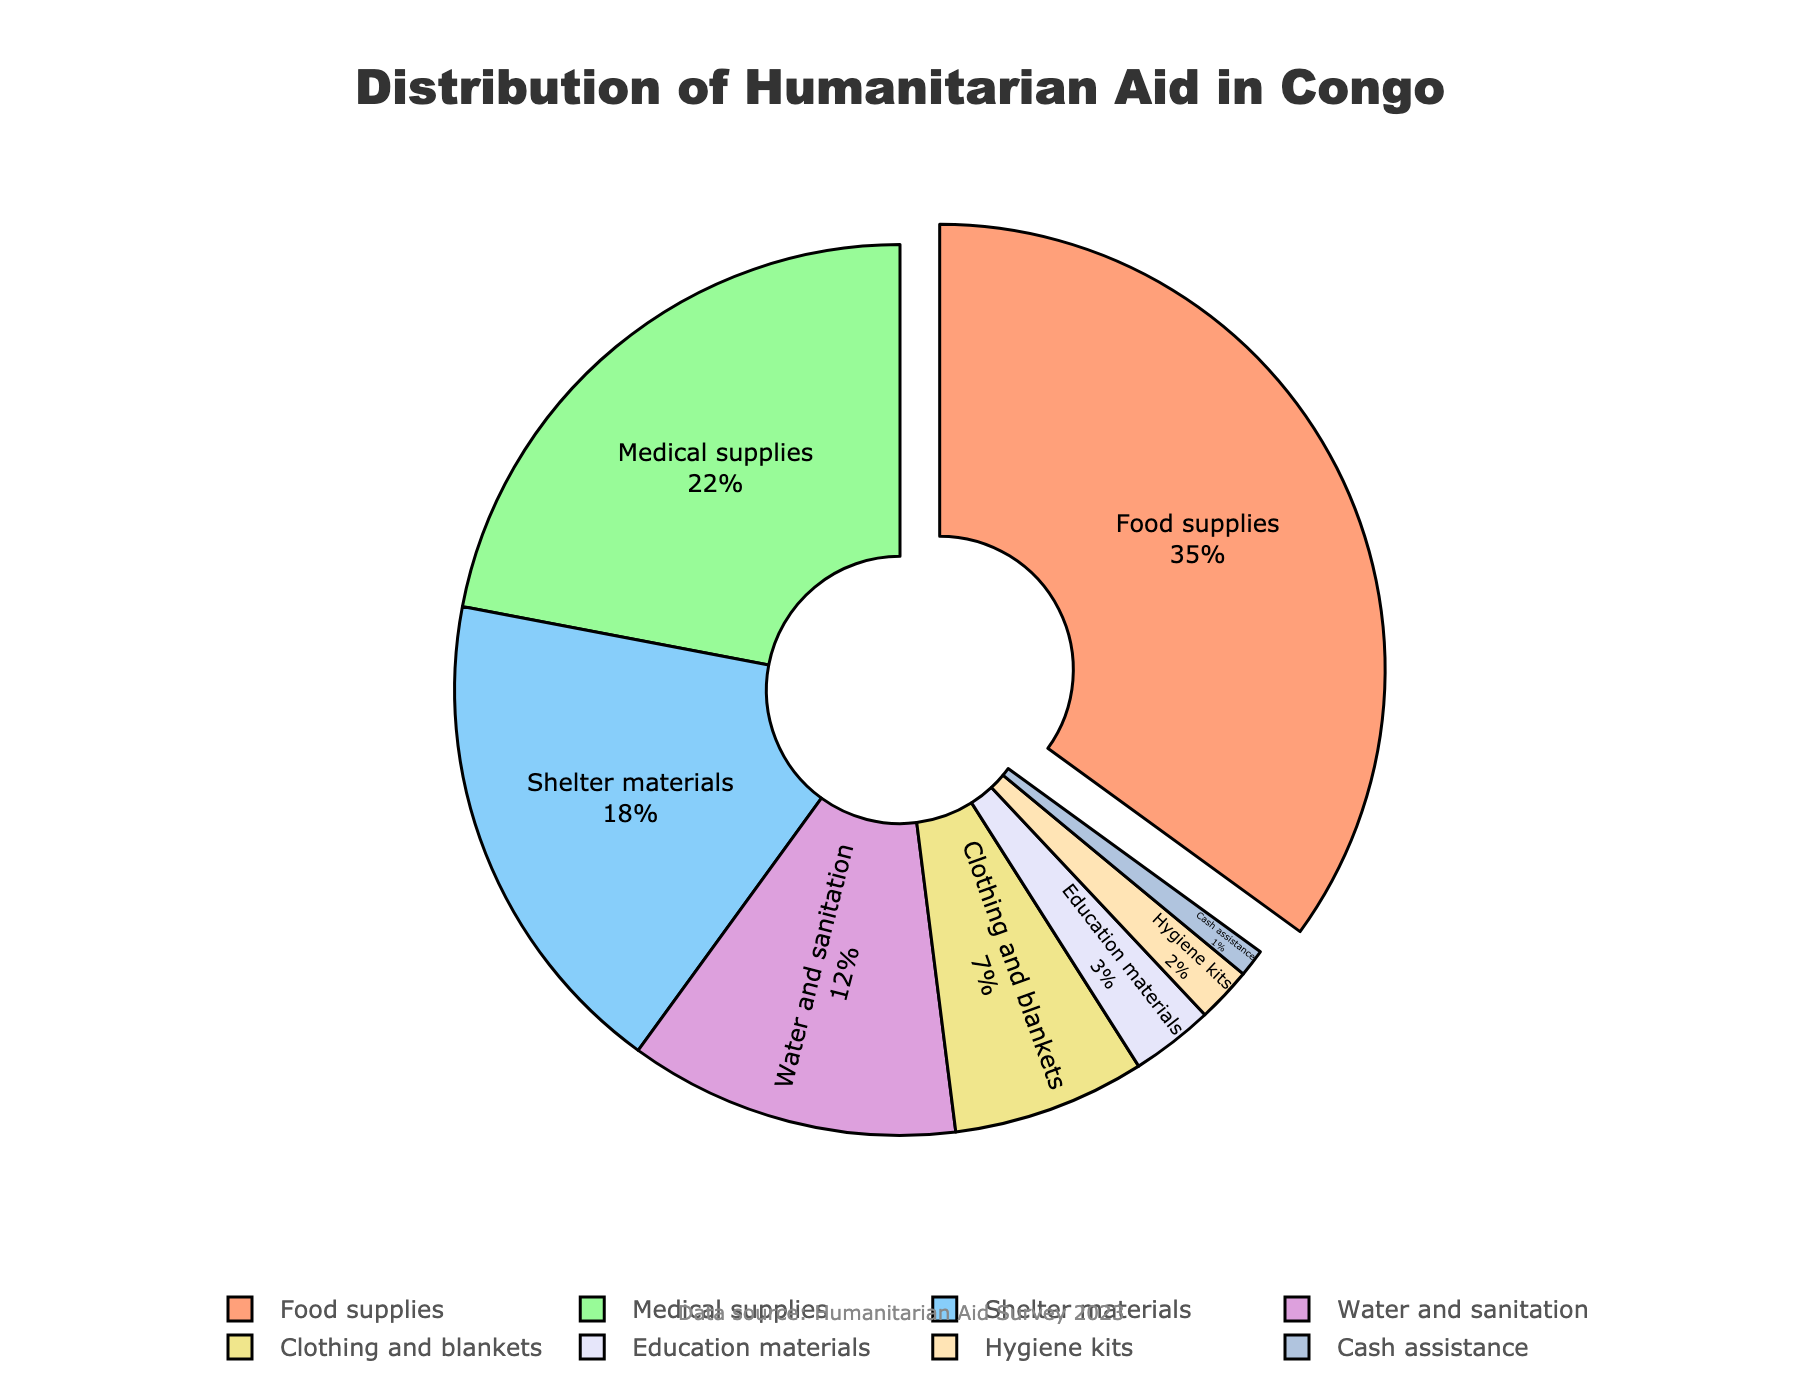What is the most common type of aid received by conflict-affected communities? The pie chart shows that food supplies have the largest segment, making it the most common type of aid received.
Answer: Food supplies How much more common is food supplies compared to medical supplies? Food supplies comprise 35% of the aid, while medical supplies comprise 22%. The difference is 35% - 22% = 13%.
Answer: 13% What is the combined percentage of shelter materials and water and sanitation? Shelter materials are 18% and water and sanitation are 12%. Adding them together, 18% + 12% = 30%.
Answer: 30% Which aid type has the smallest proportion? The pie chart shows that cash assistance has the smallest segment, indicating it has the smallest proportion.
Answer: Cash assistance Compare the proportion of food supplies to the combined proportion of clothing and blankets and education materials. Food supplies are 35%. Clothing and blankets are 7%, and education materials are 3%, making their combined proportion 7% + 3% = 10%.
Answer: Food supplies Which aid type is represented by the light purple segment? The light purple segment represents shelter materials.
Answer: Shelter materials What is the total percentage of aid types that are below 10%? Education materials (3%), hygiene kits (2%), and cash assistance (1%) are below 10%. Adding them together, 3% + 2% + 1% = 6%.
Answer: 6% What is the difference between the percentage of medical supplies and shelter materials? Medical supplies are 22%, and shelter materials are 18%. The difference is 22% - 18% = 4%.
Answer: 4% Which aid types together make up more than half of the aid distribution? Food supplies (35%) and medical supplies (22%) together make up 35% + 22% = 57%.
Answer: Food supplies and medical supplies Is the percentage of education materials higher or lower than hygiene kits? Education materials are 3%, and hygiene kits are 2%. Education materials are higher.
Answer: Higher 